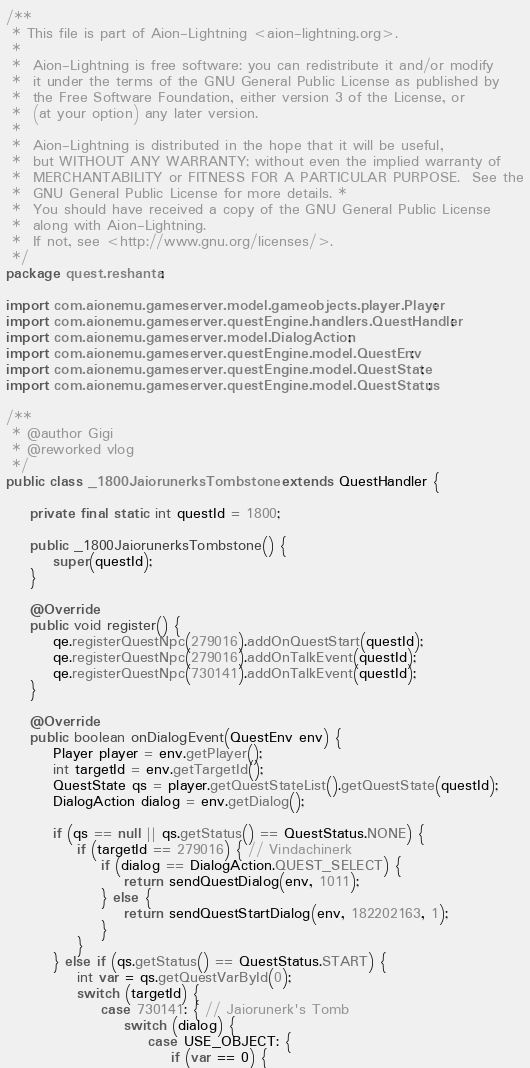<code> <loc_0><loc_0><loc_500><loc_500><_Java_>/**
 * This file is part of Aion-Lightning <aion-lightning.org>.
 *
 *  Aion-Lightning is free software: you can redistribute it and/or modify
 *  it under the terms of the GNU General Public License as published by
 *  the Free Software Foundation, either version 3 of the License, or
 *  (at your option) any later version.
 *
 *  Aion-Lightning is distributed in the hope that it will be useful,
 *  but WITHOUT ANY WARRANTY; without even the implied warranty of
 *  MERCHANTABILITY or FITNESS FOR A PARTICULAR PURPOSE.  See the
 *  GNU General Public License for more details. *
 *  You should have received a copy of the GNU General Public License
 *  along with Aion-Lightning.
 *  If not, see <http://www.gnu.org/licenses/>.
 */
package quest.reshanta;

import com.aionemu.gameserver.model.gameobjects.player.Player;
import com.aionemu.gameserver.questEngine.handlers.QuestHandler;
import com.aionemu.gameserver.model.DialogAction;
import com.aionemu.gameserver.questEngine.model.QuestEnv;
import com.aionemu.gameserver.questEngine.model.QuestState;
import com.aionemu.gameserver.questEngine.model.QuestStatus;

/**
 * @author Gigi
 * @reworked vlog
 */
public class _1800JaiorunerksTombstone extends QuestHandler {

    private final static int questId = 1800;

    public _1800JaiorunerksTombstone() {
        super(questId);
    }

    @Override
    public void register() {
        qe.registerQuestNpc(279016).addOnQuestStart(questId);
        qe.registerQuestNpc(279016).addOnTalkEvent(questId);
        qe.registerQuestNpc(730141).addOnTalkEvent(questId);
    }

    @Override
    public boolean onDialogEvent(QuestEnv env) {
        Player player = env.getPlayer();
        int targetId = env.getTargetId();
        QuestState qs = player.getQuestStateList().getQuestState(questId);
        DialogAction dialog = env.getDialog();

        if (qs == null || qs.getStatus() == QuestStatus.NONE) {
            if (targetId == 279016) { // Vindachinerk
                if (dialog == DialogAction.QUEST_SELECT) {
                    return sendQuestDialog(env, 1011);
                } else {
                    return sendQuestStartDialog(env, 182202163, 1);
                }
            }
        } else if (qs.getStatus() == QuestStatus.START) {
            int var = qs.getQuestVarById(0);
            switch (targetId) {
                case 730141: { // Jaiorunerk's Tomb
                    switch (dialog) {
                        case USE_OBJECT: {
                            if (var == 0) {</code> 